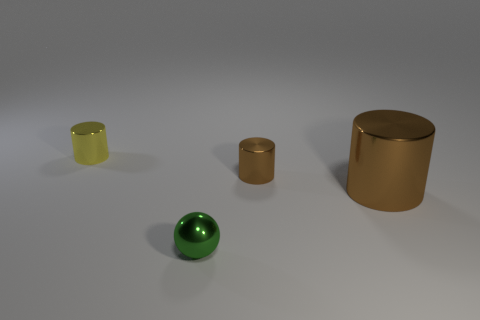How many brown cylinders must be subtracted to get 1 brown cylinders? 1 Subtract all blue spheres. Subtract all brown cylinders. How many spheres are left? 1 Add 4 purple blocks. How many objects exist? 8 Subtract all cylinders. How many objects are left? 1 Subtract 0 brown cubes. How many objects are left? 4 Subtract all small green metal things. Subtract all big cyan cylinders. How many objects are left? 3 Add 3 tiny balls. How many tiny balls are left? 4 Add 4 small yellow metallic cylinders. How many small yellow metallic cylinders exist? 5 